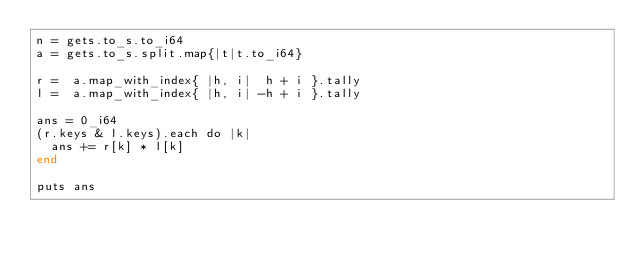Convert code to text. <code><loc_0><loc_0><loc_500><loc_500><_Crystal_>n = gets.to_s.to_i64
a = gets.to_s.split.map{|t|t.to_i64}

r =  a.map_with_index{ |h, i|  h + i }.tally
l =  a.map_with_index{ |h, i| -h + i }.tally

ans = 0_i64
(r.keys & l.keys).each do |k|
  ans += r[k] * l[k]
end

puts ans</code> 